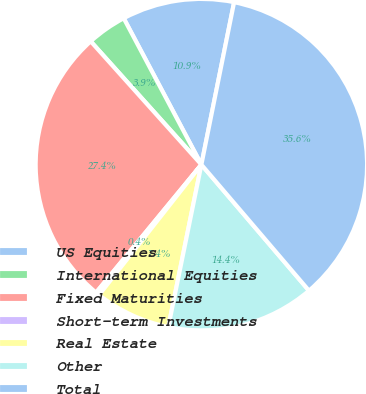Convert chart. <chart><loc_0><loc_0><loc_500><loc_500><pie_chart><fcel>US Equities<fcel>International Equities<fcel>Fixed Maturities<fcel>Short-term Investments<fcel>Real Estate<fcel>Other<fcel>Total<nl><fcel>10.93%<fcel>3.88%<fcel>27.4%<fcel>0.36%<fcel>7.4%<fcel>14.45%<fcel>35.59%<nl></chart> 